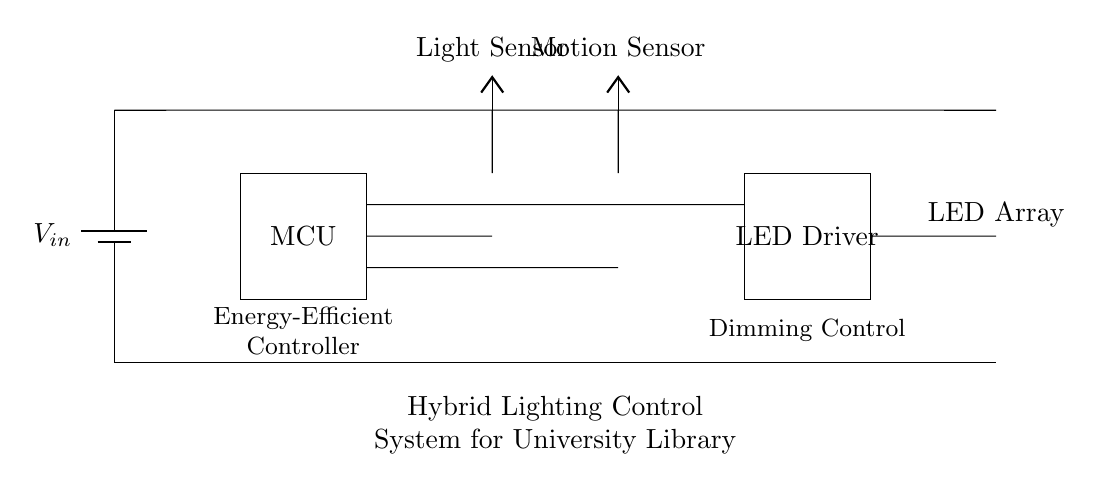What components are present in this circuit? The circuit includes a battery, microcontroller, light sensor, motion sensor, LED driver, and an LED array. Each component serves a specific function in the hybrid lighting control system.
Answer: battery, microcontroller, light sensor, motion sensor, LED driver, LED array What is the role of the microcontroller in this system? The microcontroller serves as the energy-efficient controller that processes inputs from the light and motion sensors to manage the operation of the LED driver and LED array.
Answer: energy-efficient controller How many sensors are included in the circuit? There are two sensors in the circuit: a light sensor and a motion sensor. These sensors detect environmental conditions to inform the microcontroller's actions.
Answer: two What is the function of the LED driver? The LED driver controls the power delivered to the LED array, adjusting brightness based on inputs received from the microcontroller, which is programmed to optimize energy usage.
Answer: power delivery How does the microcontroller process sensor inputs? The microcontroller analyzes data from the light and motion sensors, determining the necessary adjustments to the LED driver and LED array. This processing logic helps to efficiently manage lighting conditions in the library.
Answer: analyzes data What type of control system is implemented in this circuit? The circuit implements a hybrid lighting control system that uses both light and motion sensors to adjust lighting dynamically based on occupancy and ambient light levels, maximizing energy efficiency.
Answer: hybrid lighting control system 